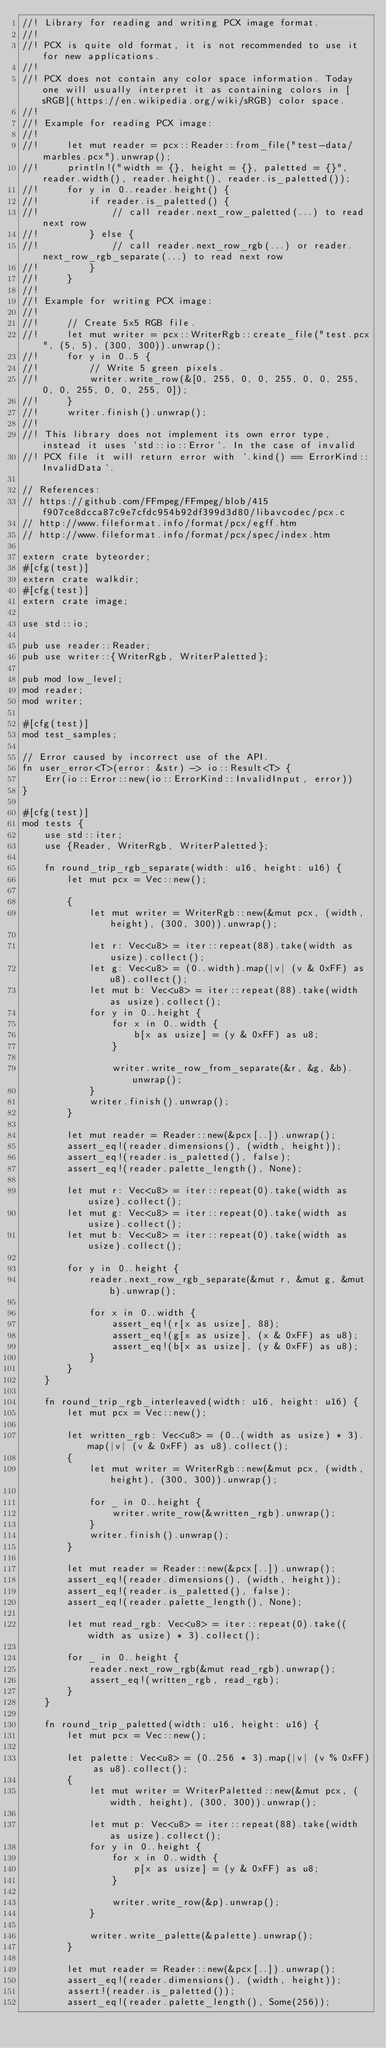<code> <loc_0><loc_0><loc_500><loc_500><_Rust_>//! Library for reading and writing PCX image format.
//!
//! PCX is quite old format, it is not recommended to use it for new applications.
//!
//! PCX does not contain any color space information. Today one will usually interpret it as containing colors in [sRGB](https://en.wikipedia.org/wiki/sRGB) color space.
//!
//! Example for reading PCX image:
//!
//!     let mut reader = pcx::Reader::from_file("test-data/marbles.pcx").unwrap();
//!     println!("width = {}, height = {}, paletted = {}", reader.width(), reader.height(), reader.is_paletted());
//!     for y in 0..reader.height() {
//!         if reader.is_paletted() {
//!             // call reader.next_row_paletted(...) to read next row
//!         } else {
//!             // call reader.next_row_rgb(...) or reader.next_row_rgb_separate(...) to read next row
//!         }
//!     }
//!
//! Example for writing PCX image:
//!
//!     // Create 5x5 RGB file.
//!     let mut writer = pcx::WriterRgb::create_file("test.pcx", (5, 5), (300, 300)).unwrap();
//!     for y in 0..5 {
//!         // Write 5 green pixels.
//!         writer.write_row(&[0, 255, 0, 0, 255, 0, 0, 255, 0, 0, 255, 0, 0, 255, 0]);
//!     }
//!     writer.finish().unwrap();
//!
//! This library does not implement its own error type, instead it uses `std::io::Error`. In the case of invalid
//! PCX file it will return error with `.kind() == ErrorKind::InvalidData`.

// References:
// https://github.com/FFmpeg/FFmpeg/blob/415f907ce8dcca87c9e7cfdc954b92df399d3d80/libavcodec/pcx.c
// http://www.fileformat.info/format/pcx/egff.htm
// http://www.fileformat.info/format/pcx/spec/index.htm

extern crate byteorder;
#[cfg(test)]
extern crate walkdir;
#[cfg(test)]
extern crate image;

use std::io;

pub use reader::Reader;
pub use writer::{WriterRgb, WriterPaletted};

pub mod low_level;
mod reader;
mod writer;

#[cfg(test)]
mod test_samples;

// Error caused by incorrect use of the API.
fn user_error<T>(error: &str) -> io::Result<T> {
    Err(io::Error::new(io::ErrorKind::InvalidInput, error))
}

#[cfg(test)]
mod tests {
    use std::iter;
    use {Reader, WriterRgb, WriterPaletted};

    fn round_trip_rgb_separate(width: u16, height: u16) {
        let mut pcx = Vec::new();

        {
            let mut writer = WriterRgb::new(&mut pcx, (width, height), (300, 300)).unwrap();

            let r: Vec<u8> = iter::repeat(88).take(width as usize).collect();
            let g: Vec<u8> = (0..width).map(|v| (v & 0xFF) as u8).collect();
            let mut b: Vec<u8> = iter::repeat(88).take(width as usize).collect();
            for y in 0..height {
                for x in 0..width {
                    b[x as usize] = (y & 0xFF) as u8;
                }

                writer.write_row_from_separate(&r, &g, &b).unwrap();
            }
            writer.finish().unwrap();
        }

        let mut reader = Reader::new(&pcx[..]).unwrap();
        assert_eq!(reader.dimensions(), (width, height));
        assert_eq!(reader.is_paletted(), false);
        assert_eq!(reader.palette_length(), None);

        let mut r: Vec<u8> = iter::repeat(0).take(width as usize).collect();
        let mut g: Vec<u8> = iter::repeat(0).take(width as usize).collect();
        let mut b: Vec<u8> = iter::repeat(0).take(width as usize).collect();

        for y in 0..height {
            reader.next_row_rgb_separate(&mut r, &mut g, &mut b).unwrap();

            for x in 0..width {
                assert_eq!(r[x as usize], 88);
                assert_eq!(g[x as usize], (x & 0xFF) as u8);
                assert_eq!(b[x as usize], (y & 0xFF) as u8);
            }
        }
    }

    fn round_trip_rgb_interleaved(width: u16, height: u16) {
        let mut pcx = Vec::new();

        let written_rgb: Vec<u8> = (0..(width as usize) * 3).map(|v| (v & 0xFF) as u8).collect();
        {
            let mut writer = WriterRgb::new(&mut pcx, (width, height), (300, 300)).unwrap();

            for _ in 0..height {
                writer.write_row(&written_rgb).unwrap();
            }
            writer.finish().unwrap();
        }

        let mut reader = Reader::new(&pcx[..]).unwrap();
        assert_eq!(reader.dimensions(), (width, height));
        assert_eq!(reader.is_paletted(), false);
        assert_eq!(reader.palette_length(), None);

        let mut read_rgb: Vec<u8> = iter::repeat(0).take((width as usize) * 3).collect();

        for _ in 0..height {
            reader.next_row_rgb(&mut read_rgb).unwrap();
            assert_eq!(written_rgb, read_rgb);
        }
    }

    fn round_trip_paletted(width: u16, height: u16) {
        let mut pcx = Vec::new();

        let palette: Vec<u8> = (0..256 * 3).map(|v| (v % 0xFF) as u8).collect();
        {
            let mut writer = WriterPaletted::new(&mut pcx, (width, height), (300, 300)).unwrap();

            let mut p: Vec<u8> = iter::repeat(88).take(width as usize).collect();
            for y in 0..height {
                for x in 0..width {
                    p[x as usize] = (y & 0xFF) as u8;
                }

                writer.write_row(&p).unwrap();
            }

            writer.write_palette(&palette).unwrap();
        }

        let mut reader = Reader::new(&pcx[..]).unwrap();
        assert_eq!(reader.dimensions(), (width, height));
        assert!(reader.is_paletted());
        assert_eq!(reader.palette_length(), Some(256));
</code> 